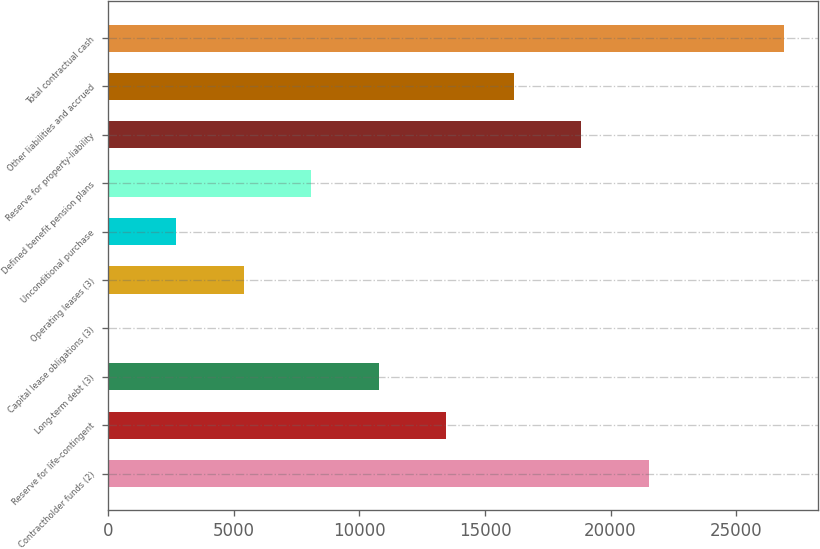Convert chart to OTSL. <chart><loc_0><loc_0><loc_500><loc_500><bar_chart><fcel>Contractholder funds (2)<fcel>Reserve for life-contingent<fcel>Long-term debt (3)<fcel>Capital lease obligations (3)<fcel>Operating leases (3)<fcel>Unconditional purchase<fcel>Defined benefit pension plans<fcel>Reserve for property-liability<fcel>Other liabilities and accrued<fcel>Total contractual cash<nl><fcel>21530.4<fcel>13461<fcel>10771.2<fcel>12<fcel>5391.6<fcel>2701.8<fcel>8081.4<fcel>18840.6<fcel>16150.8<fcel>26910<nl></chart> 